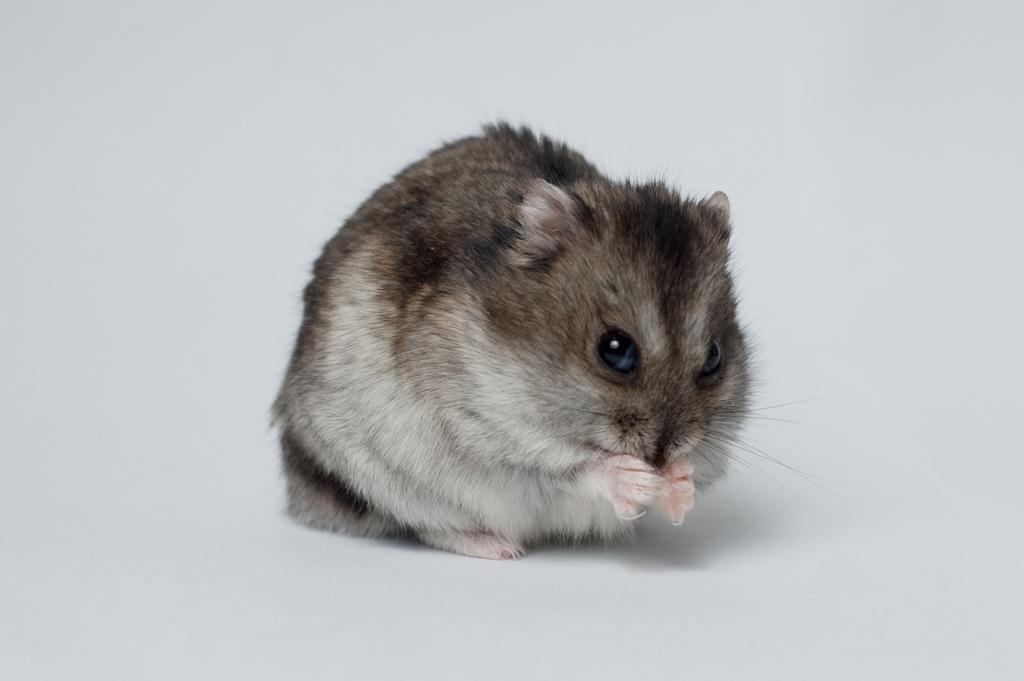What animal is present in the image? There is a rat in the picture. Where is the rat located in the image? The rat is sitting on the floor. What is the color of the floor in the image? The floor is white in color. What type of vessel can be seen at the dock in the image? There is no vessel or dock present in the image; it only features a rat sitting on a white floor. How does the rat show respect to the other animals in the image? There are no other animals present in the image, so it is not possible to determine how the rat shows respect. 